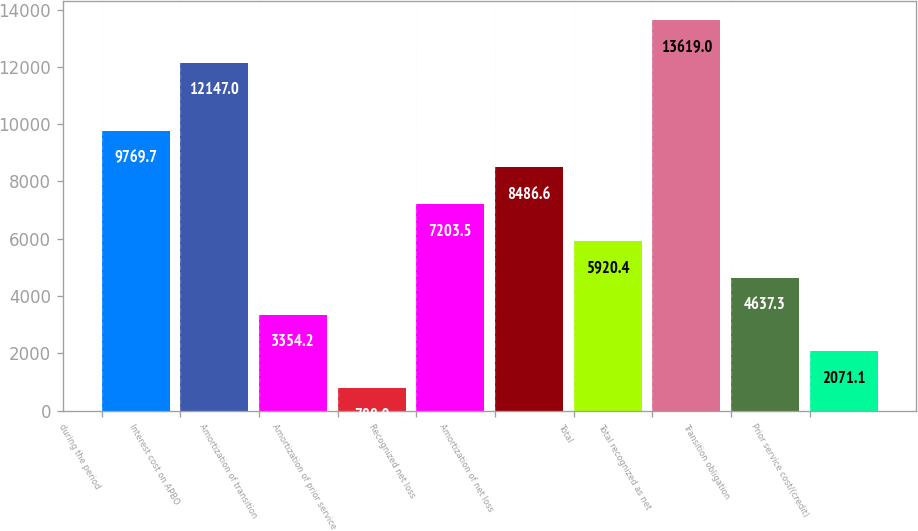Convert chart. <chart><loc_0><loc_0><loc_500><loc_500><bar_chart><fcel>during the period<fcel>Interest cost on APBO<fcel>Amortization of transition<fcel>Amortization of prior service<fcel>Recognized net loss<fcel>Amortization of net loss<fcel>Total<fcel>Total recognized as net<fcel>Transition obligation<fcel>Prior service cost/(credit)<nl><fcel>9769.7<fcel>12147<fcel>3354.2<fcel>788<fcel>7203.5<fcel>8486.6<fcel>5920.4<fcel>13619<fcel>4637.3<fcel>2071.1<nl></chart> 